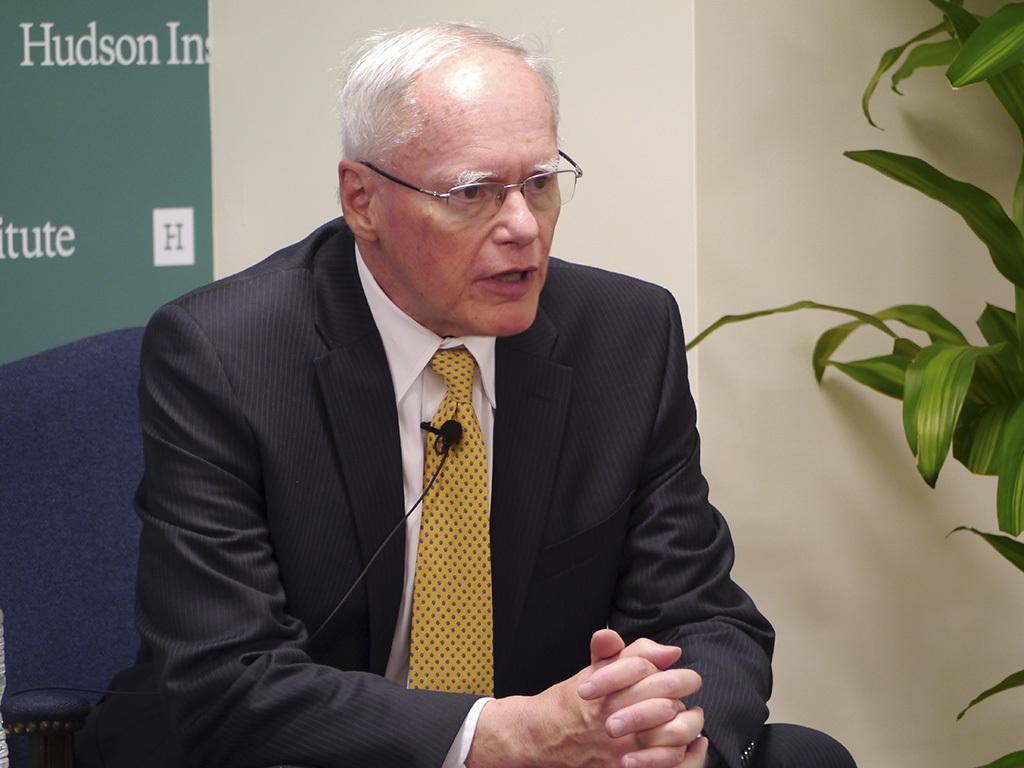Please provide a concise description of this image. In this picture we can see a man wore a blazer, tie, spectacles, sitting on a chair and in the background we can see the wall, leaves. 